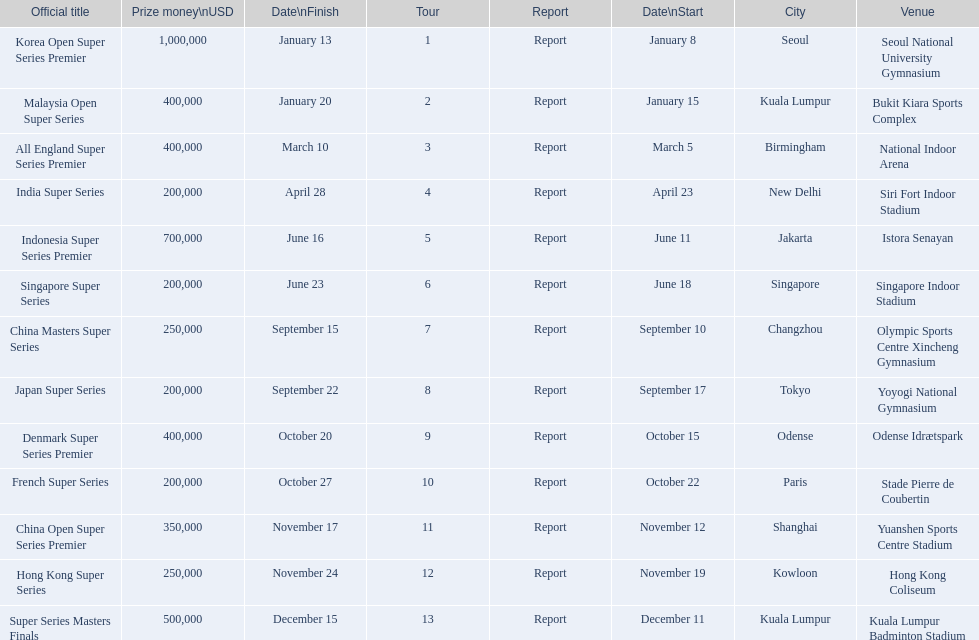How many occur in the last six months of the year? 7. 